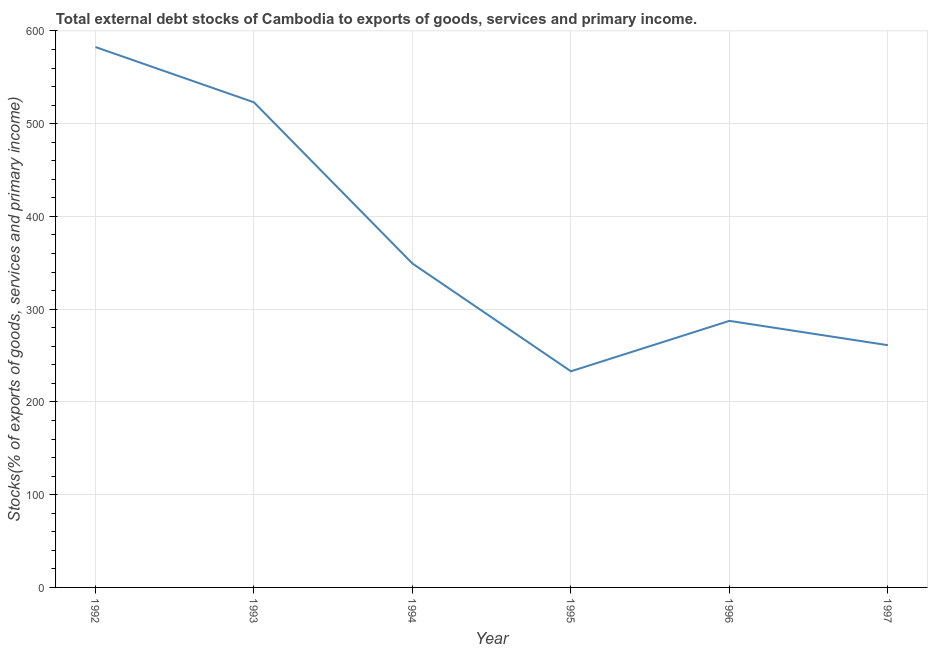What is the external debt stocks in 1996?
Your response must be concise. 287.39. Across all years, what is the maximum external debt stocks?
Offer a very short reply. 582.63. Across all years, what is the minimum external debt stocks?
Offer a very short reply. 233.02. In which year was the external debt stocks minimum?
Offer a very short reply. 1995. What is the sum of the external debt stocks?
Offer a very short reply. 2236.48. What is the difference between the external debt stocks in 1992 and 1993?
Your answer should be very brief. 59.6. What is the average external debt stocks per year?
Provide a short and direct response. 372.75. What is the median external debt stocks?
Your answer should be very brief. 318.32. In how many years, is the external debt stocks greater than 180 %?
Give a very brief answer. 6. Do a majority of the years between 1995 and 1994 (inclusive) have external debt stocks greater than 300 %?
Provide a succinct answer. No. What is the ratio of the external debt stocks in 1992 to that in 1997?
Ensure brevity in your answer.  2.23. Is the external debt stocks in 1992 less than that in 1996?
Your response must be concise. No. Is the difference between the external debt stocks in 1993 and 1994 greater than the difference between any two years?
Keep it short and to the point. No. What is the difference between the highest and the second highest external debt stocks?
Ensure brevity in your answer.  59.6. What is the difference between the highest and the lowest external debt stocks?
Ensure brevity in your answer.  349.61. Does the external debt stocks monotonically increase over the years?
Offer a very short reply. No. How many lines are there?
Ensure brevity in your answer.  1. What is the difference between two consecutive major ticks on the Y-axis?
Your answer should be very brief. 100. Are the values on the major ticks of Y-axis written in scientific E-notation?
Make the answer very short. No. Does the graph contain grids?
Your response must be concise. Yes. What is the title of the graph?
Provide a succinct answer. Total external debt stocks of Cambodia to exports of goods, services and primary income. What is the label or title of the Y-axis?
Provide a short and direct response. Stocks(% of exports of goods, services and primary income). What is the Stocks(% of exports of goods, services and primary income) in 1992?
Make the answer very short. 582.63. What is the Stocks(% of exports of goods, services and primary income) of 1993?
Make the answer very short. 523.03. What is the Stocks(% of exports of goods, services and primary income) in 1994?
Provide a succinct answer. 349.25. What is the Stocks(% of exports of goods, services and primary income) in 1995?
Your answer should be very brief. 233.02. What is the Stocks(% of exports of goods, services and primary income) in 1996?
Your answer should be compact. 287.39. What is the Stocks(% of exports of goods, services and primary income) of 1997?
Provide a succinct answer. 261.16. What is the difference between the Stocks(% of exports of goods, services and primary income) in 1992 and 1993?
Your answer should be compact. 59.6. What is the difference between the Stocks(% of exports of goods, services and primary income) in 1992 and 1994?
Give a very brief answer. 233.38. What is the difference between the Stocks(% of exports of goods, services and primary income) in 1992 and 1995?
Your answer should be compact. 349.61. What is the difference between the Stocks(% of exports of goods, services and primary income) in 1992 and 1996?
Ensure brevity in your answer.  295.24. What is the difference between the Stocks(% of exports of goods, services and primary income) in 1992 and 1997?
Your answer should be very brief. 321.47. What is the difference between the Stocks(% of exports of goods, services and primary income) in 1993 and 1994?
Provide a short and direct response. 173.78. What is the difference between the Stocks(% of exports of goods, services and primary income) in 1993 and 1995?
Offer a terse response. 290.01. What is the difference between the Stocks(% of exports of goods, services and primary income) in 1993 and 1996?
Offer a very short reply. 235.64. What is the difference between the Stocks(% of exports of goods, services and primary income) in 1993 and 1997?
Your response must be concise. 261.87. What is the difference between the Stocks(% of exports of goods, services and primary income) in 1994 and 1995?
Give a very brief answer. 116.23. What is the difference between the Stocks(% of exports of goods, services and primary income) in 1994 and 1996?
Offer a terse response. 61.86. What is the difference between the Stocks(% of exports of goods, services and primary income) in 1994 and 1997?
Ensure brevity in your answer.  88.09. What is the difference between the Stocks(% of exports of goods, services and primary income) in 1995 and 1996?
Ensure brevity in your answer.  -54.37. What is the difference between the Stocks(% of exports of goods, services and primary income) in 1995 and 1997?
Ensure brevity in your answer.  -28.14. What is the difference between the Stocks(% of exports of goods, services and primary income) in 1996 and 1997?
Give a very brief answer. 26.23. What is the ratio of the Stocks(% of exports of goods, services and primary income) in 1992 to that in 1993?
Your response must be concise. 1.11. What is the ratio of the Stocks(% of exports of goods, services and primary income) in 1992 to that in 1994?
Offer a terse response. 1.67. What is the ratio of the Stocks(% of exports of goods, services and primary income) in 1992 to that in 1996?
Give a very brief answer. 2.03. What is the ratio of the Stocks(% of exports of goods, services and primary income) in 1992 to that in 1997?
Offer a very short reply. 2.23. What is the ratio of the Stocks(% of exports of goods, services and primary income) in 1993 to that in 1994?
Offer a terse response. 1.5. What is the ratio of the Stocks(% of exports of goods, services and primary income) in 1993 to that in 1995?
Your answer should be very brief. 2.25. What is the ratio of the Stocks(% of exports of goods, services and primary income) in 1993 to that in 1996?
Give a very brief answer. 1.82. What is the ratio of the Stocks(% of exports of goods, services and primary income) in 1993 to that in 1997?
Your answer should be compact. 2. What is the ratio of the Stocks(% of exports of goods, services and primary income) in 1994 to that in 1995?
Keep it short and to the point. 1.5. What is the ratio of the Stocks(% of exports of goods, services and primary income) in 1994 to that in 1996?
Your answer should be compact. 1.22. What is the ratio of the Stocks(% of exports of goods, services and primary income) in 1994 to that in 1997?
Your answer should be very brief. 1.34. What is the ratio of the Stocks(% of exports of goods, services and primary income) in 1995 to that in 1996?
Keep it short and to the point. 0.81. What is the ratio of the Stocks(% of exports of goods, services and primary income) in 1995 to that in 1997?
Give a very brief answer. 0.89. What is the ratio of the Stocks(% of exports of goods, services and primary income) in 1996 to that in 1997?
Provide a short and direct response. 1.1. 